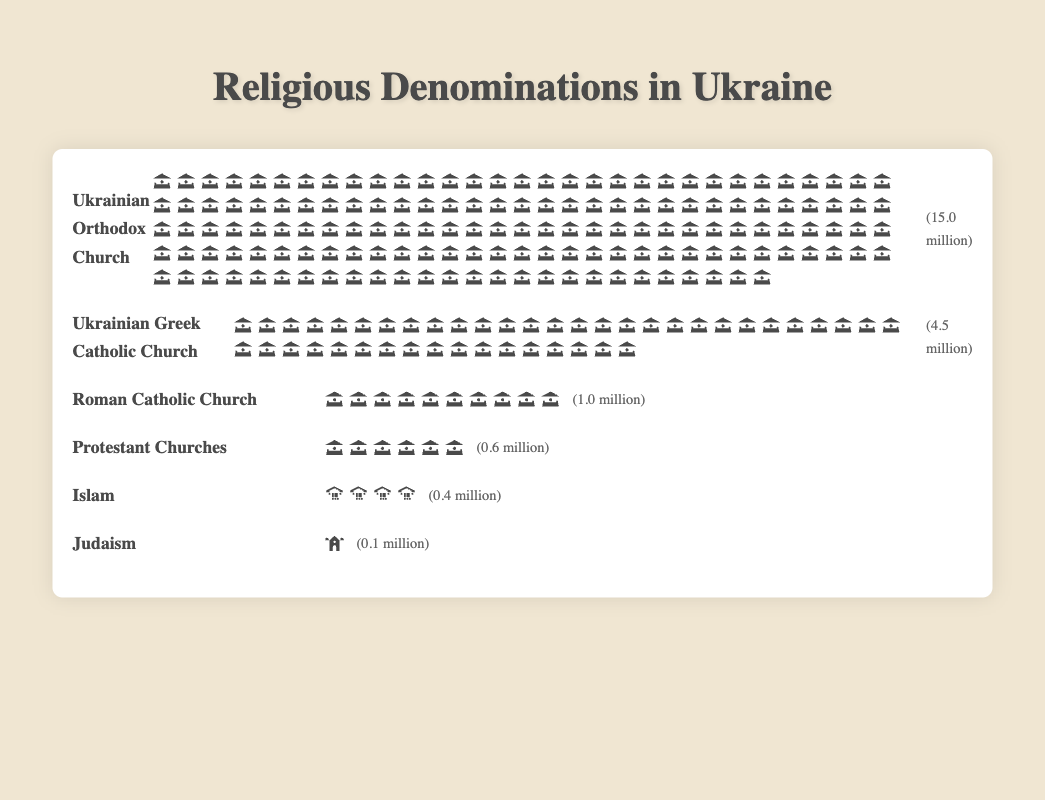How many denominations are represented in the chart? By counting the number of unique denomination names listed in the chart, we can see there are 6.
Answer: 6 Which denomination has the highest number of followers? By looking at the isotype plot, the Ukrainian Orthodox Church has the most icons representing the most followers.
Answer: Ukrainian Orthodox Church What is the total number of followers for the Protestant Churches and Judaism combined? The Protestant Churches have 600,000 followers and Judaism has 100,000 followers. Adding these together gives 700,000 followers.
Answer: 700,000 How many more followers does the Ukrainian Greek Catholic Church have compared to Islam? The Ukrainian Greek Catholic Church has 4,500,000 followers whereas Islam has 400,000 followers. By subtracting 400,000 from 4,500,000, we find the difference is 4,100,000 followers.
Answer: 4,100,000 What type of icon is used to represent the Roman Catholic Church? By observing the icons for each denomination, we see that a church icon is used for the Roman Catholic Church.
Answer: church Comparing the Ukrainian Orthodox Church and the Roman Catholic Church, which one has more followers and by how many? The Ukrainian Orthodox Church has 15,000,000 followers and the Roman Catholic Church has 1,000,000 followers. Subtracting 1,000,000 from 15,000,000, we find the Ukrainian Orthodox Church has 14,000,000 more followers.
Answer: 14,000,000 If each icon represents 100,000 followers, how many icons should be used for the Ukrainian Greek Catholic Church? The Ukrainian Greek Catholic Church has 4,500,000 followers. Dividing this by 100,000, we get 45 icons.
Answer: 45 On average, how many followers do each of the represented denominations have? Summing the number of followers for all denominations (15,000,000 + 4,500,000 + 1,000,000 + 600,000 + 400,000 + 100,000) gives 21,600,000. Dividing this by the 6 denominations, we find the average number of followers is 3,600,000.
Answer: 3,600,000 